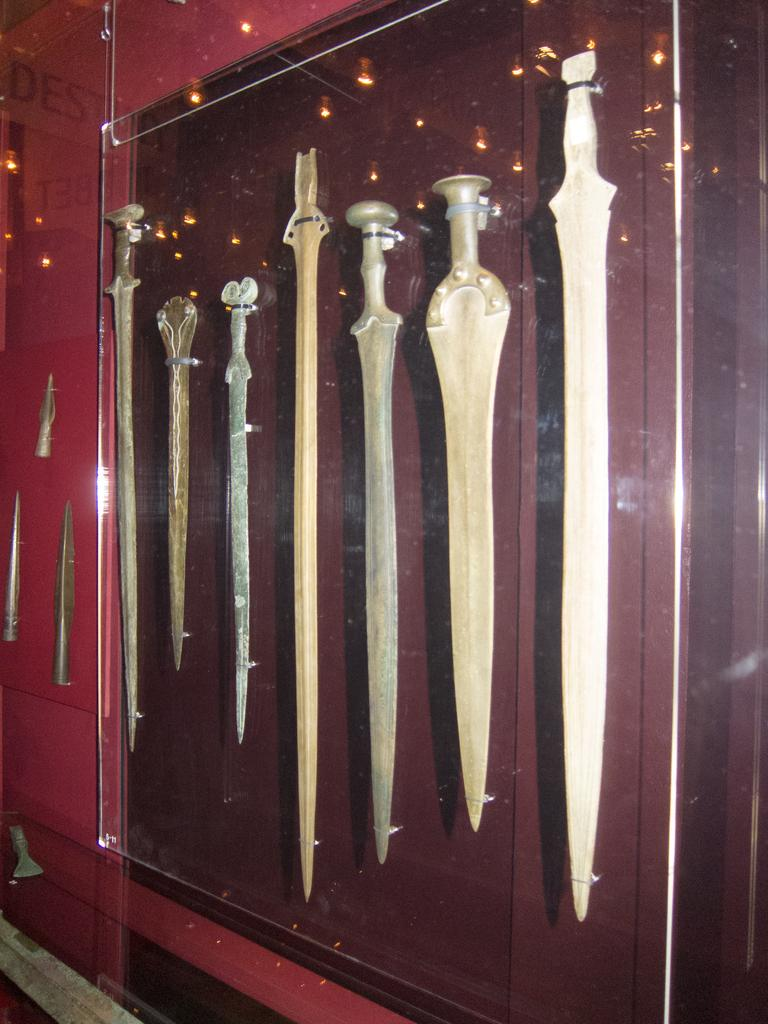What objects can be seen in the picture? There are swords in the picture. How are the swords arranged in the image? The swords are placed in various locations. Is there anything covering the swords in the picture? Yes, there is a glass covering the swords. What statement does the person in the picture say to the swords? There is no person present in the image, so it is not possible to determine what statement they might say to the swords. 